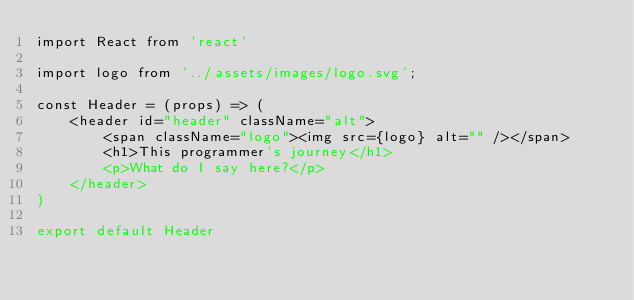Convert code to text. <code><loc_0><loc_0><loc_500><loc_500><_JavaScript_>import React from 'react'

import logo from '../assets/images/logo.svg';

const Header = (props) => (
    <header id="header" className="alt">
        <span className="logo"><img src={logo} alt="" /></span>
        <h1>This programmer's journey</h1>
        <p>What do I say here?</p>
    </header>
)

export default Header
</code> 